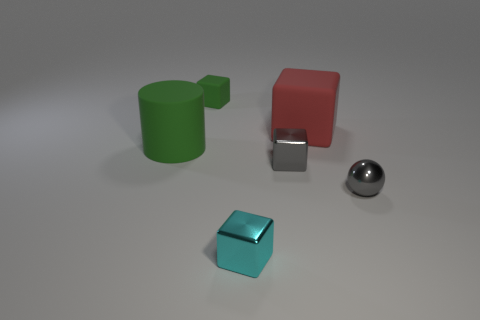Subtract all cyan shiny blocks. How many blocks are left? 3 Add 2 gray shiny objects. How many objects exist? 8 Subtract all red cubes. How many cubes are left? 3 Subtract all blocks. How many objects are left? 2 Subtract all blue metallic objects. Subtract all small cyan cubes. How many objects are left? 5 Add 6 small gray objects. How many small gray objects are left? 8 Add 2 tiny green objects. How many tiny green objects exist? 3 Subtract 1 cyan cubes. How many objects are left? 5 Subtract 1 blocks. How many blocks are left? 3 Subtract all cyan cylinders. Subtract all brown spheres. How many cylinders are left? 1 